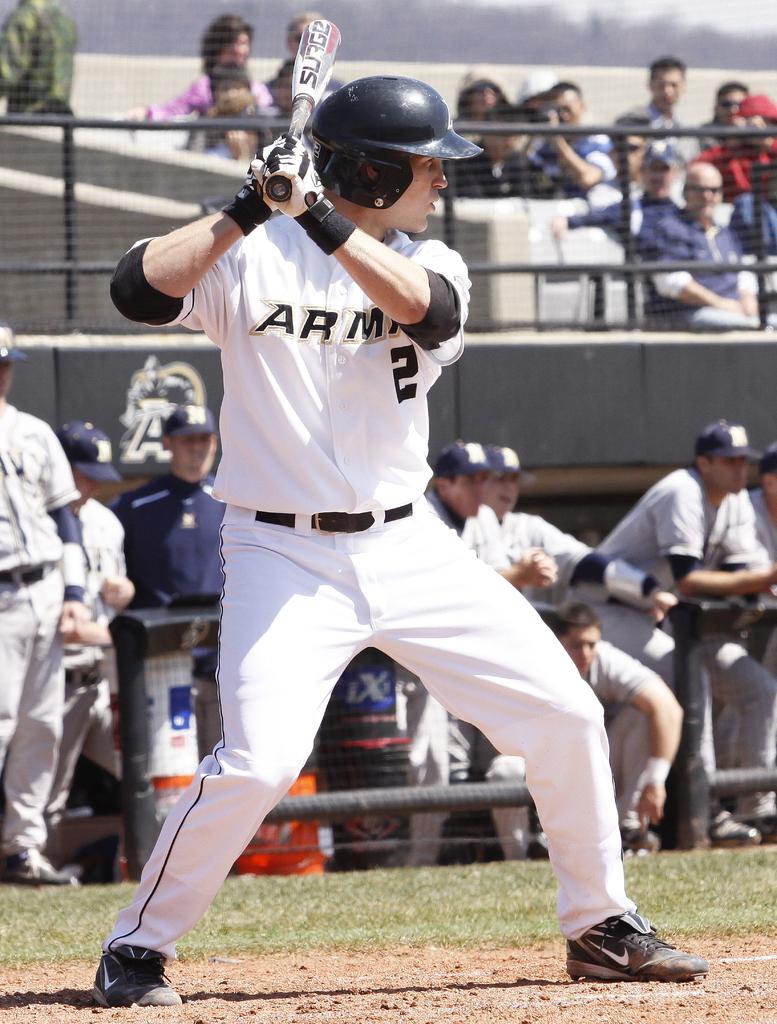What number is up to bat for the army team?
Keep it short and to the point. 2. What team is this?/?
Keep it short and to the point. Army. 